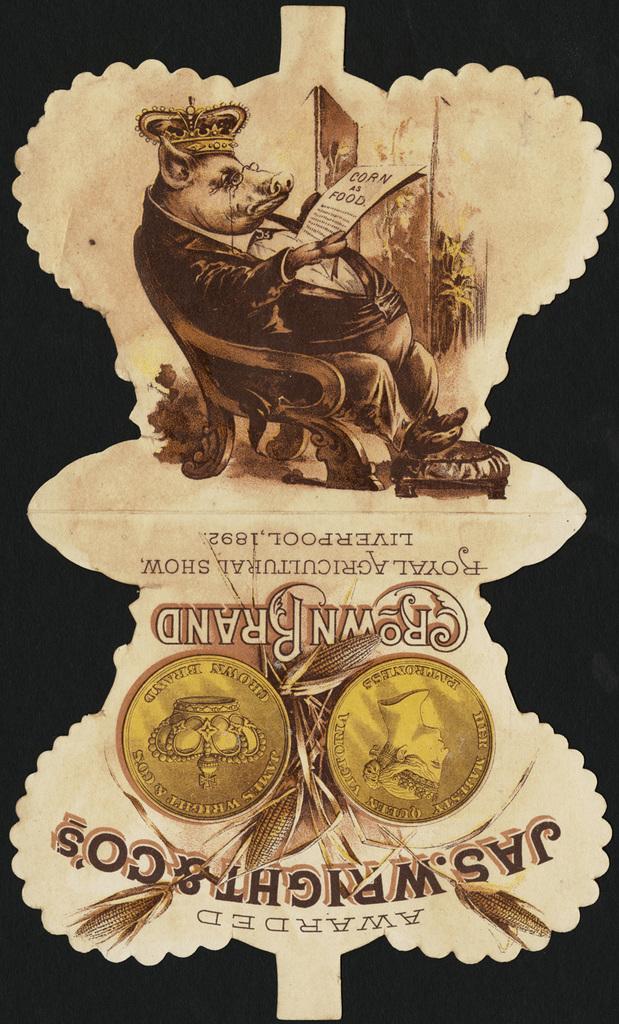What city was this company founded in?
Your response must be concise. Liverpool. What is the pig reading?
Provide a short and direct response. Corn as food. 